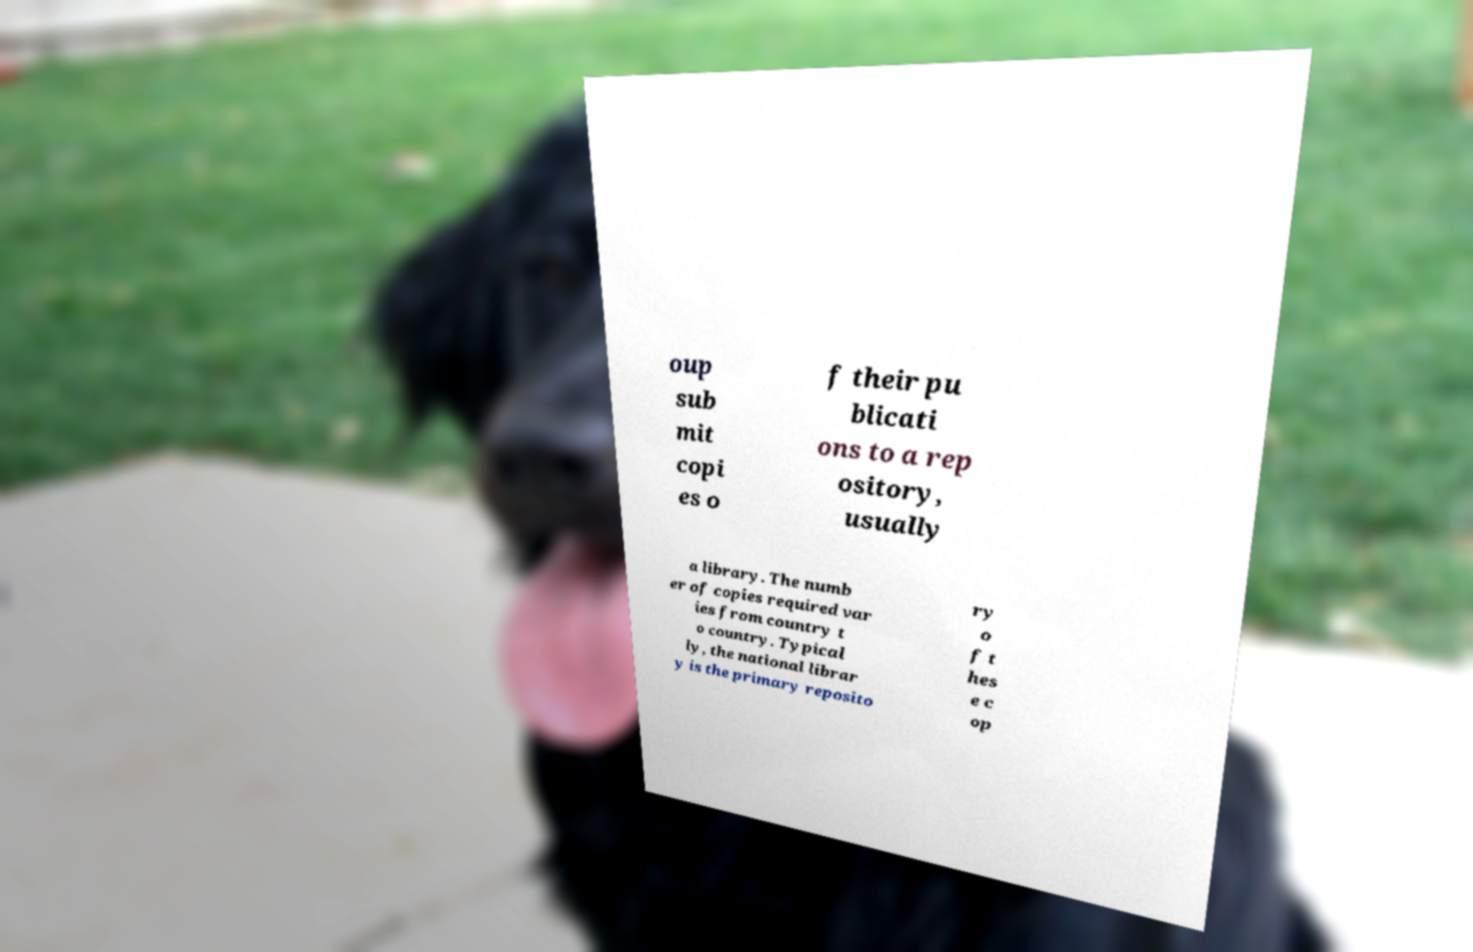Could you assist in decoding the text presented in this image and type it out clearly? oup sub mit copi es o f their pu blicati ons to a rep ository, usually a library. The numb er of copies required var ies from country t o country. Typical ly, the national librar y is the primary reposito ry o f t hes e c op 